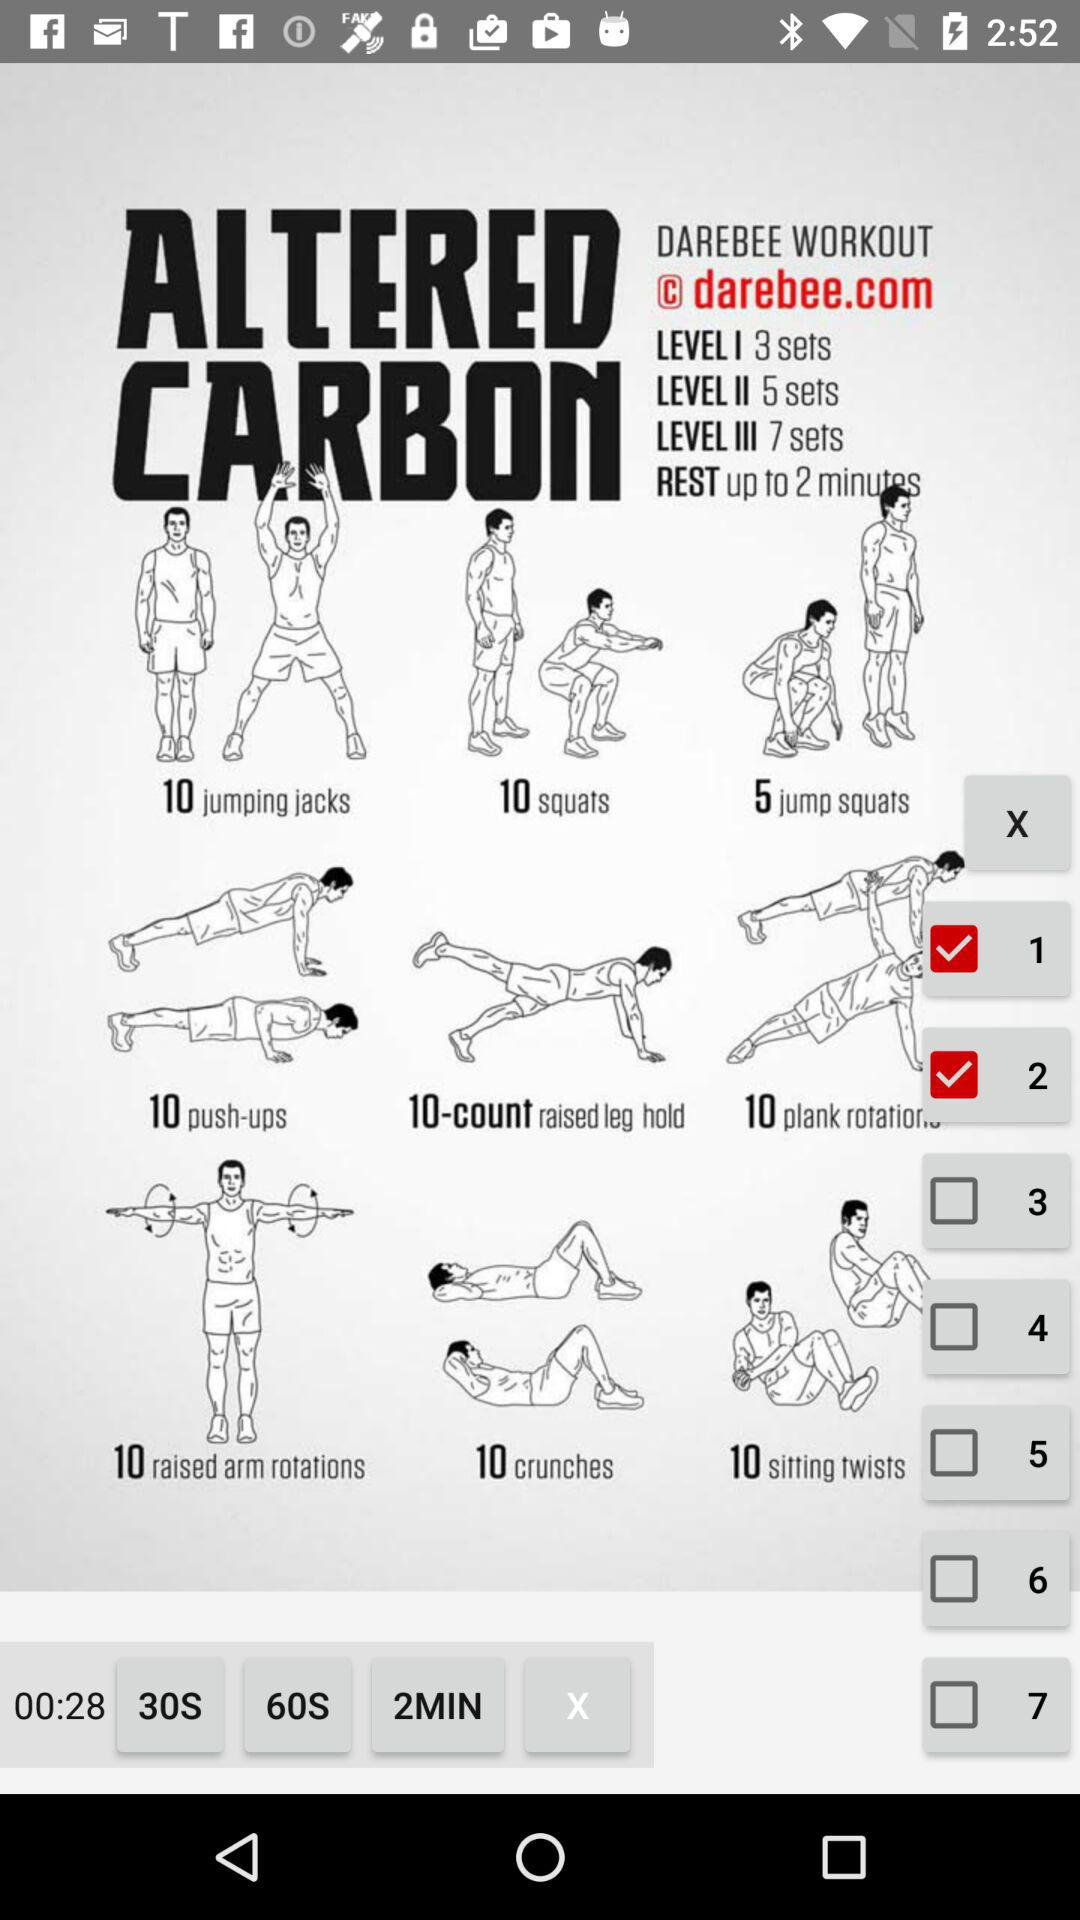How many sets of raised arm rotations are there?
Answer the question using a single word or phrase. 3 